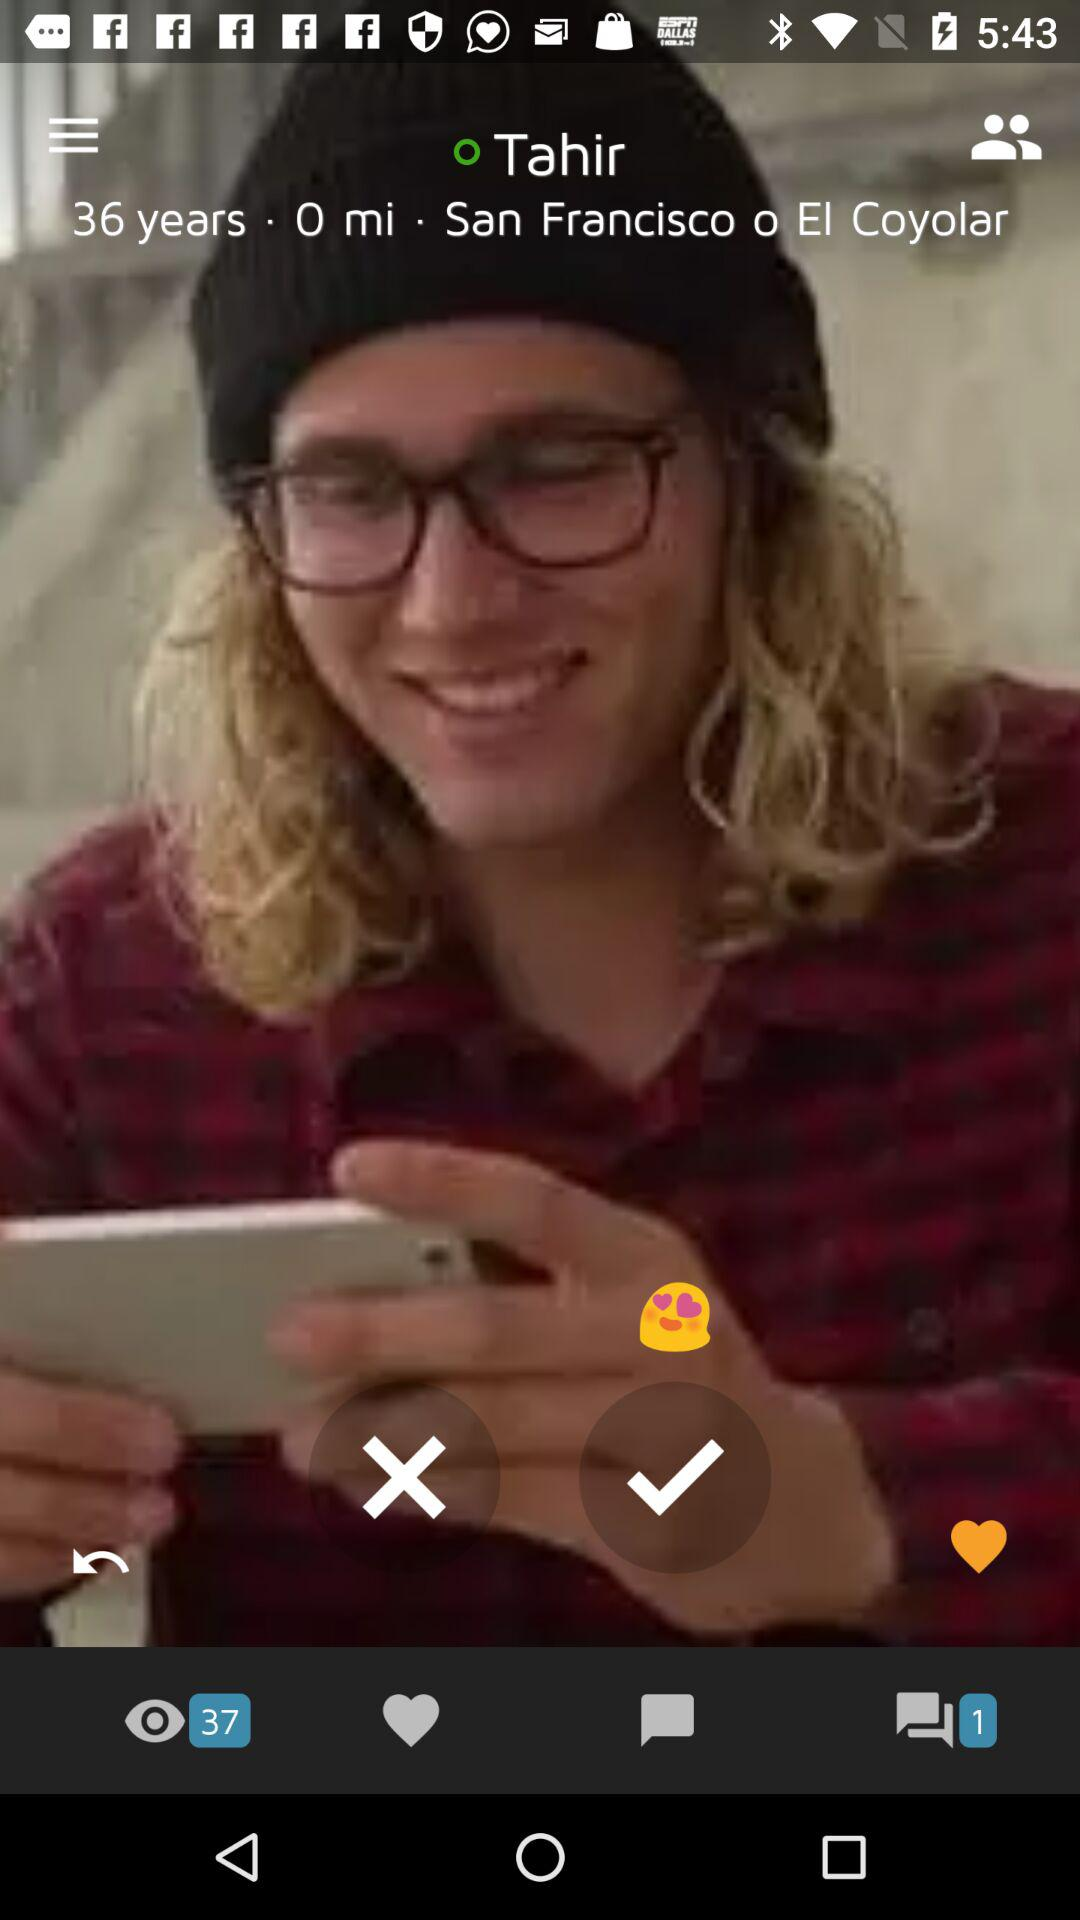What is the age of Tahir? The age of Tahir is 36 years. 